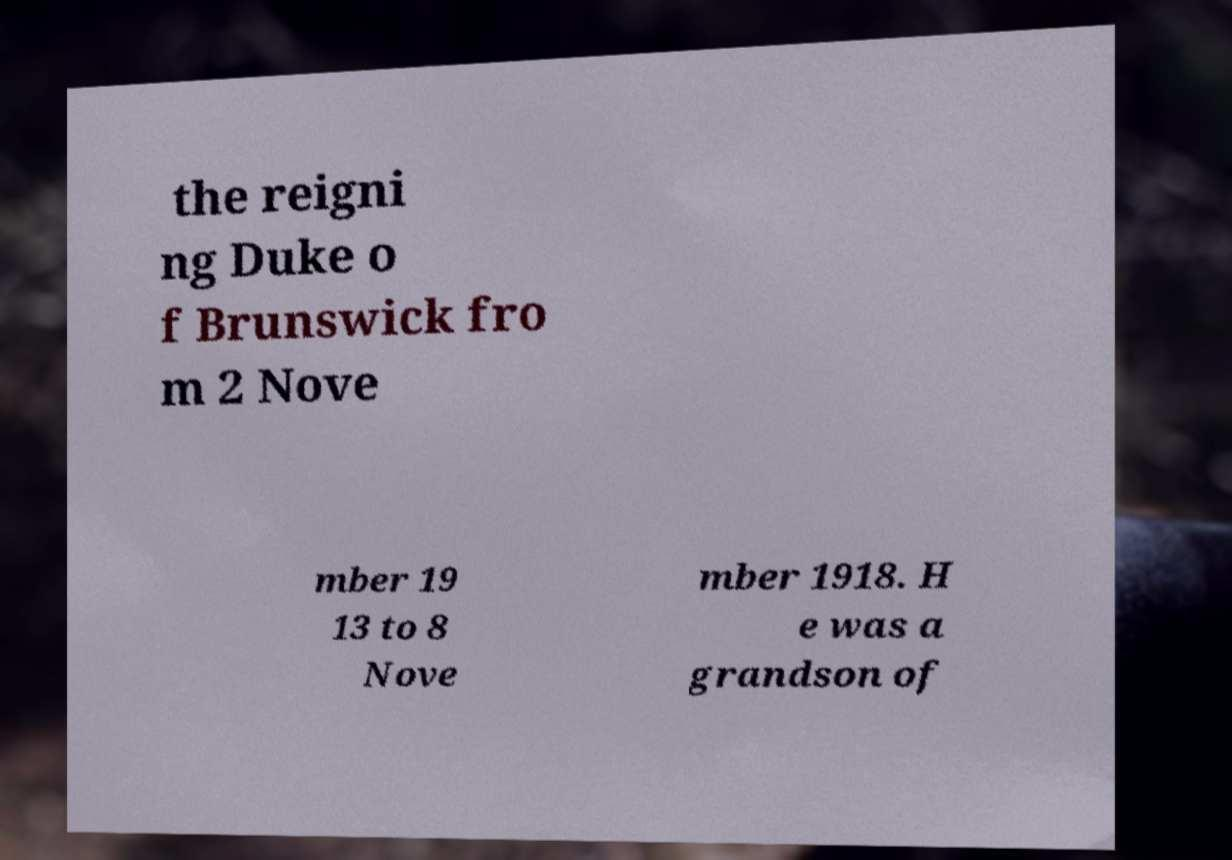There's text embedded in this image that I need extracted. Can you transcribe it verbatim? the reigni ng Duke o f Brunswick fro m 2 Nove mber 19 13 to 8 Nove mber 1918. H e was a grandson of 